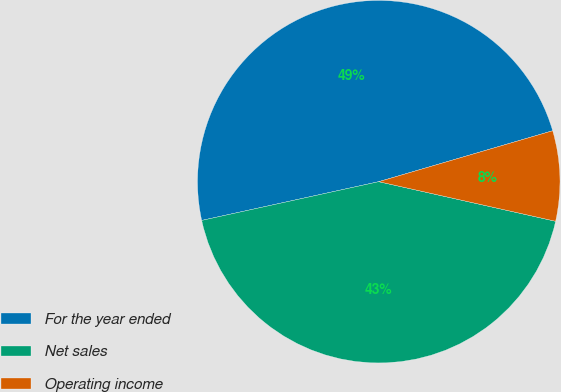Convert chart to OTSL. <chart><loc_0><loc_0><loc_500><loc_500><pie_chart><fcel>For the year ended<fcel>Net sales<fcel>Operating income<nl><fcel>48.9%<fcel>43.07%<fcel>8.04%<nl></chart> 